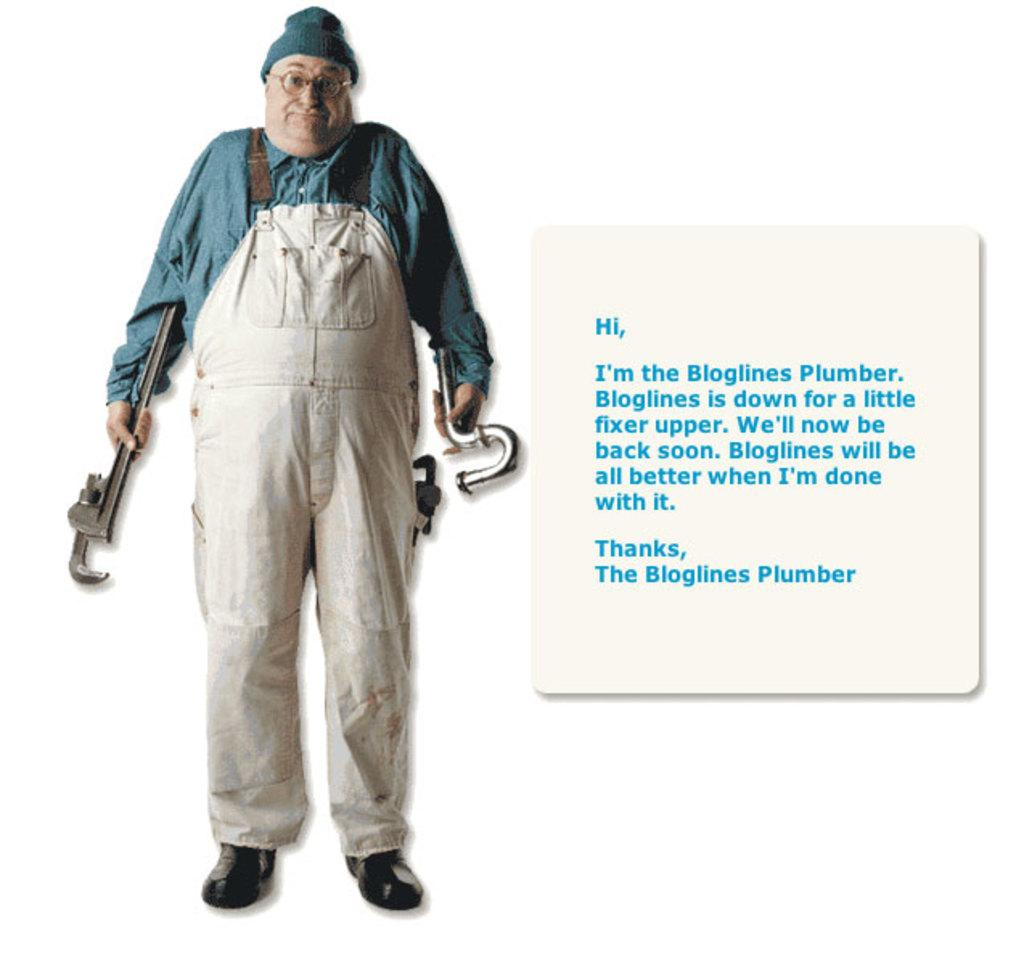What is the main subject of the image? There is a person standing in the image. What is the person holding in the image? The person is holding tools. Can you describe any other objects or elements in the image? There is a poster with text in the image. What type of science experiment is being conducted by the person in the image? There is no indication of a science experiment in the image; the person is simply holding tools. Can you see an airplane in the image? No, there is no airplane present in the image. 